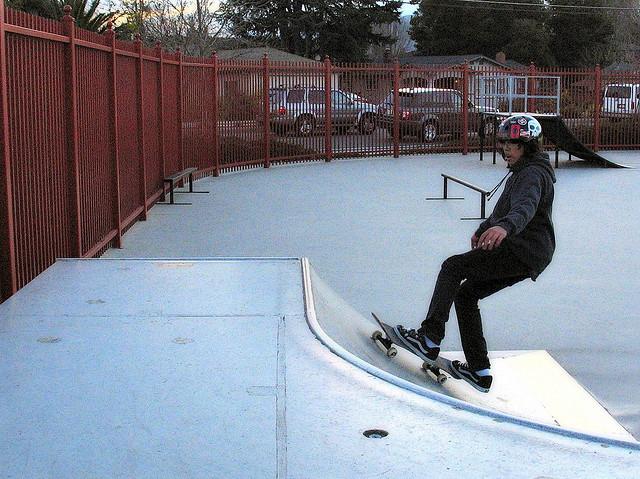What is the person doing?
Short answer required. Skateboarding. Why is the skater wearing a helmet?
Give a very brief answer. Safety. Is this picture taken in a skateboard park?
Answer briefly. Yes. 